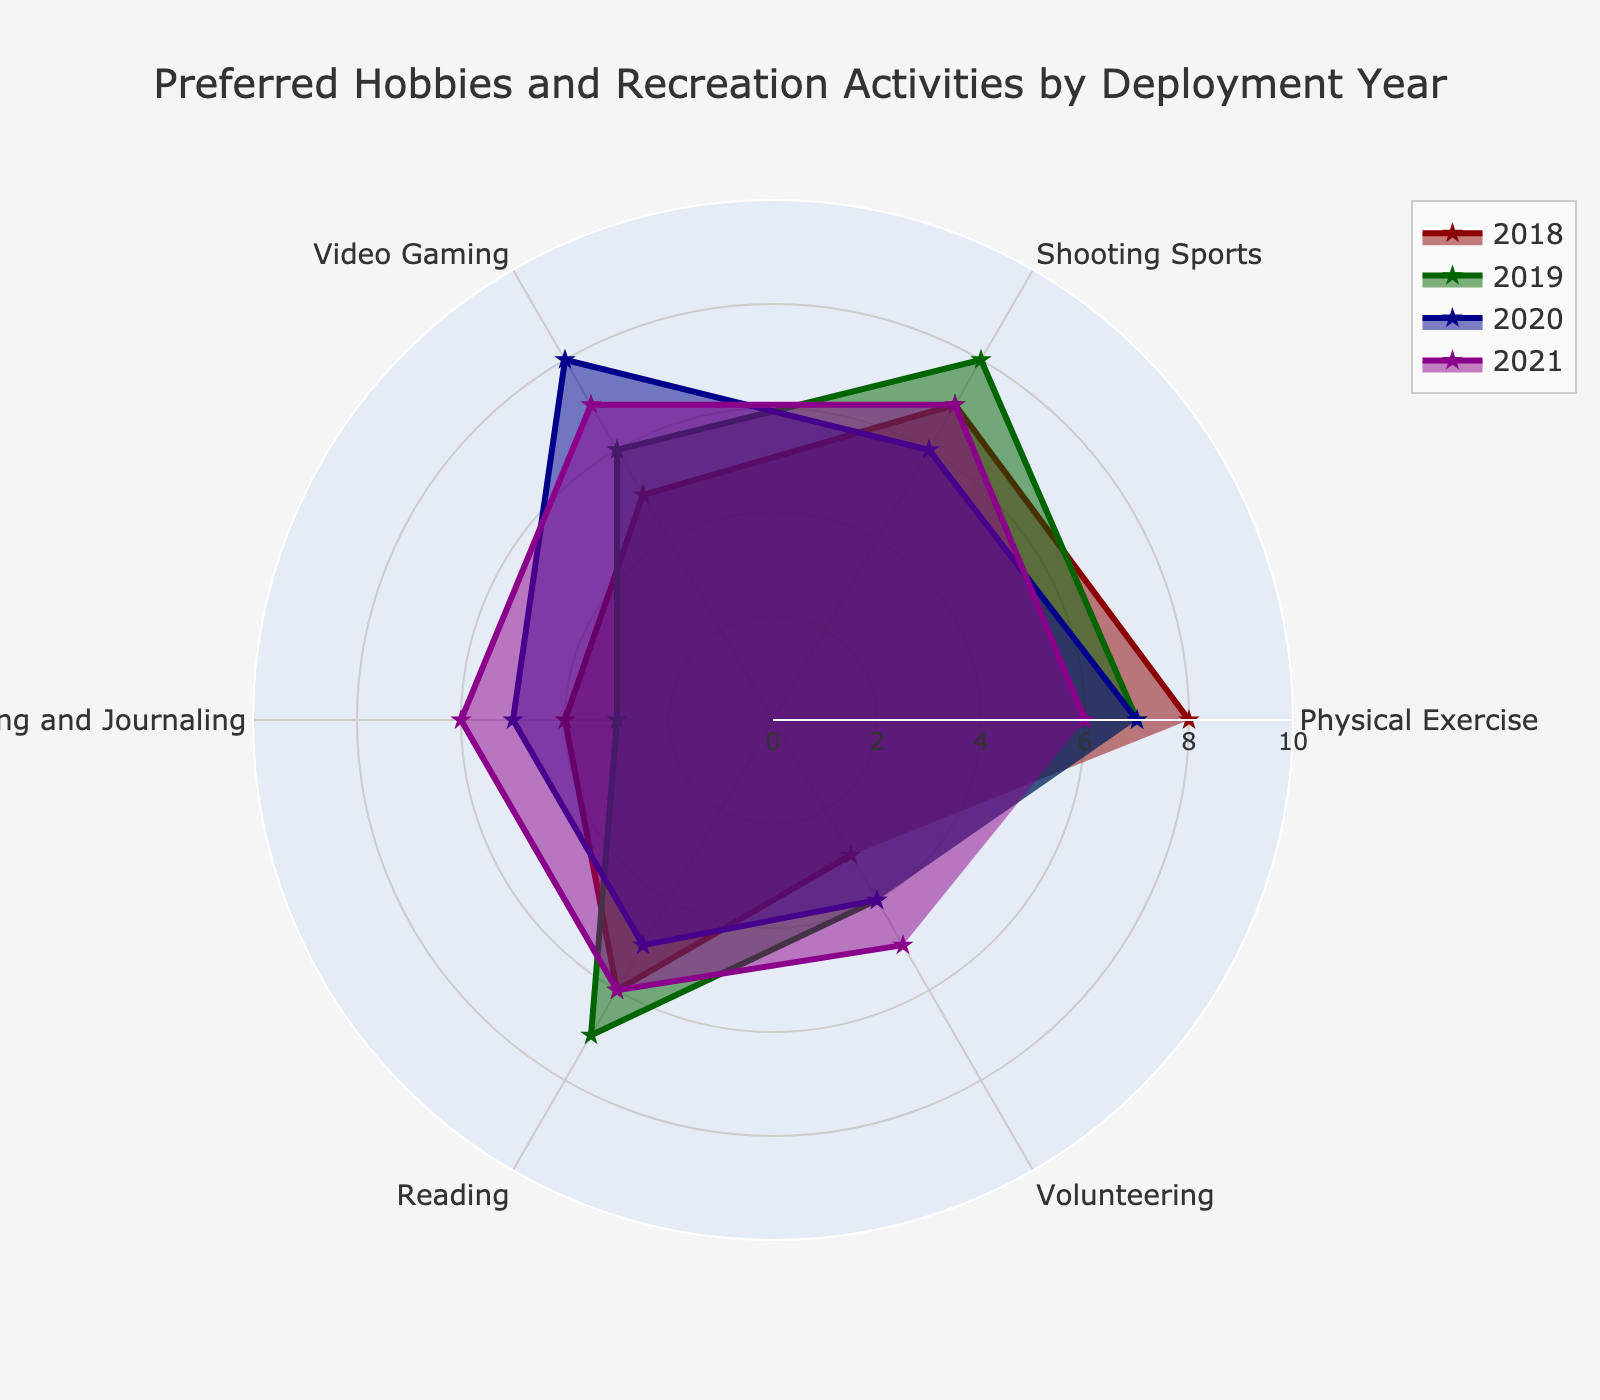What's the title of the figure? The title is clearly written at the top of the chart and can be easily read.
Answer: Preferred Hobbies and Recreation Activities by Deployment Year Which hobby had the highest interest in 2018? By looking at the deployment year 2018 and checking which hobby has the longest bar, the highest value is found.
Answer: Physical Exercise What is the overall trend in interest for Video Gaming from 2018 to 2021? By comparing the values of Video Gaming across the years, we can observe if it increased, decreased, or remained the same.
Answer: Increased How does the interest in Writing and Journaling in 2020 compare to 2019? Compare the values for Writing and Journaling in the years 2019 and 2020. In 2019, it is 3, and in 2020, it is 5.
Answer: Increased What is the average interest in Reading across all years? Sum the Reading values for all years (6 + 7 + 5 + 6) and divide by the number of years, which is 4.
Answer: 6 In which year was Volunteering the highest? By checking the Volunteering values across all the years, locate the year with the highest value.
Answer: 2021 Which hobby shows the most uniform interest over the years? By observing the chart, identify the hobby whose values change the least across all years. Writing and Journaling has values 4, 3, 5, 6.
Answer: Physical Exercise and Reading How does interest in Shooting Sports in 2020 compare with 2019? Compare the values for Shooting Sports in the years 2019 and 2020, which are 8 and 6 respectively.
Answer: Decreased What is the median interest value for Physical Exercise across all years? List Physical Exercise values (8, 7, 7, 6), and find the middle value or the average of the two middle values. The sequence is already sorted: (6, 7, 7, 8).
Answer: 7 Which year had the lowest interest in Volunteering? By checking the Volunteering values across all the years, locate the year with the lowest value.
Answer: 2018 